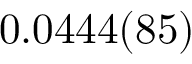<formula> <loc_0><loc_0><loc_500><loc_500>0 . 0 4 4 4 ( 8 5 )</formula> 